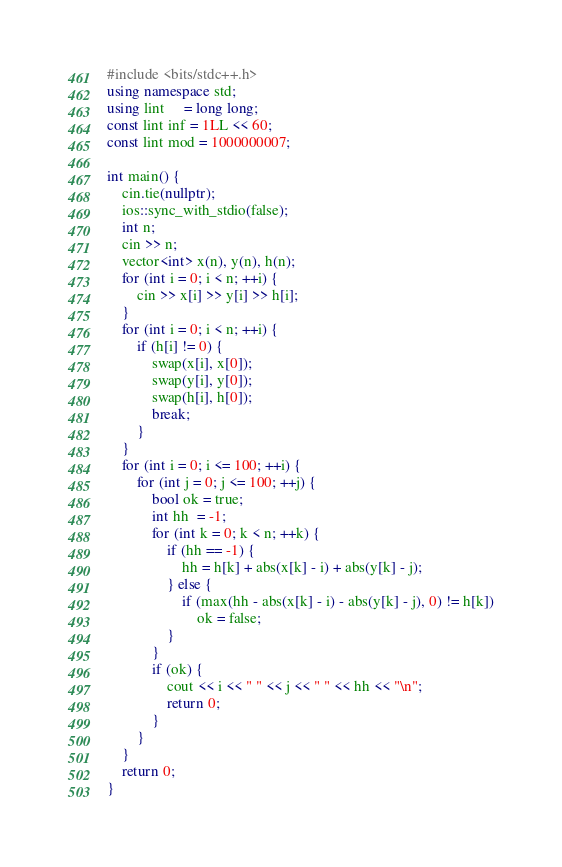<code> <loc_0><loc_0><loc_500><loc_500><_C++_>#include <bits/stdc++.h>
using namespace std;
using lint     = long long;
const lint inf = 1LL << 60;
const lint mod = 1000000007;

int main() {
    cin.tie(nullptr);
    ios::sync_with_stdio(false);
    int n;
    cin >> n;
    vector<int> x(n), y(n), h(n);
    for (int i = 0; i < n; ++i) {
        cin >> x[i] >> y[i] >> h[i];
    }
    for (int i = 0; i < n; ++i) {
        if (h[i] != 0) {
            swap(x[i], x[0]);
            swap(y[i], y[0]);
            swap(h[i], h[0]);
            break;
        }
    }
    for (int i = 0; i <= 100; ++i) {
        for (int j = 0; j <= 100; ++j) {
            bool ok = true;
            int hh  = -1;
            for (int k = 0; k < n; ++k) {
                if (hh == -1) {
                    hh = h[k] + abs(x[k] - i) + abs(y[k] - j);
                } else {
                    if (max(hh - abs(x[k] - i) - abs(y[k] - j), 0) != h[k])
                        ok = false;
                }
            }
            if (ok) {
                cout << i << " " << j << " " << hh << "\n";
                return 0;
            }
        }
    }
    return 0;
}</code> 